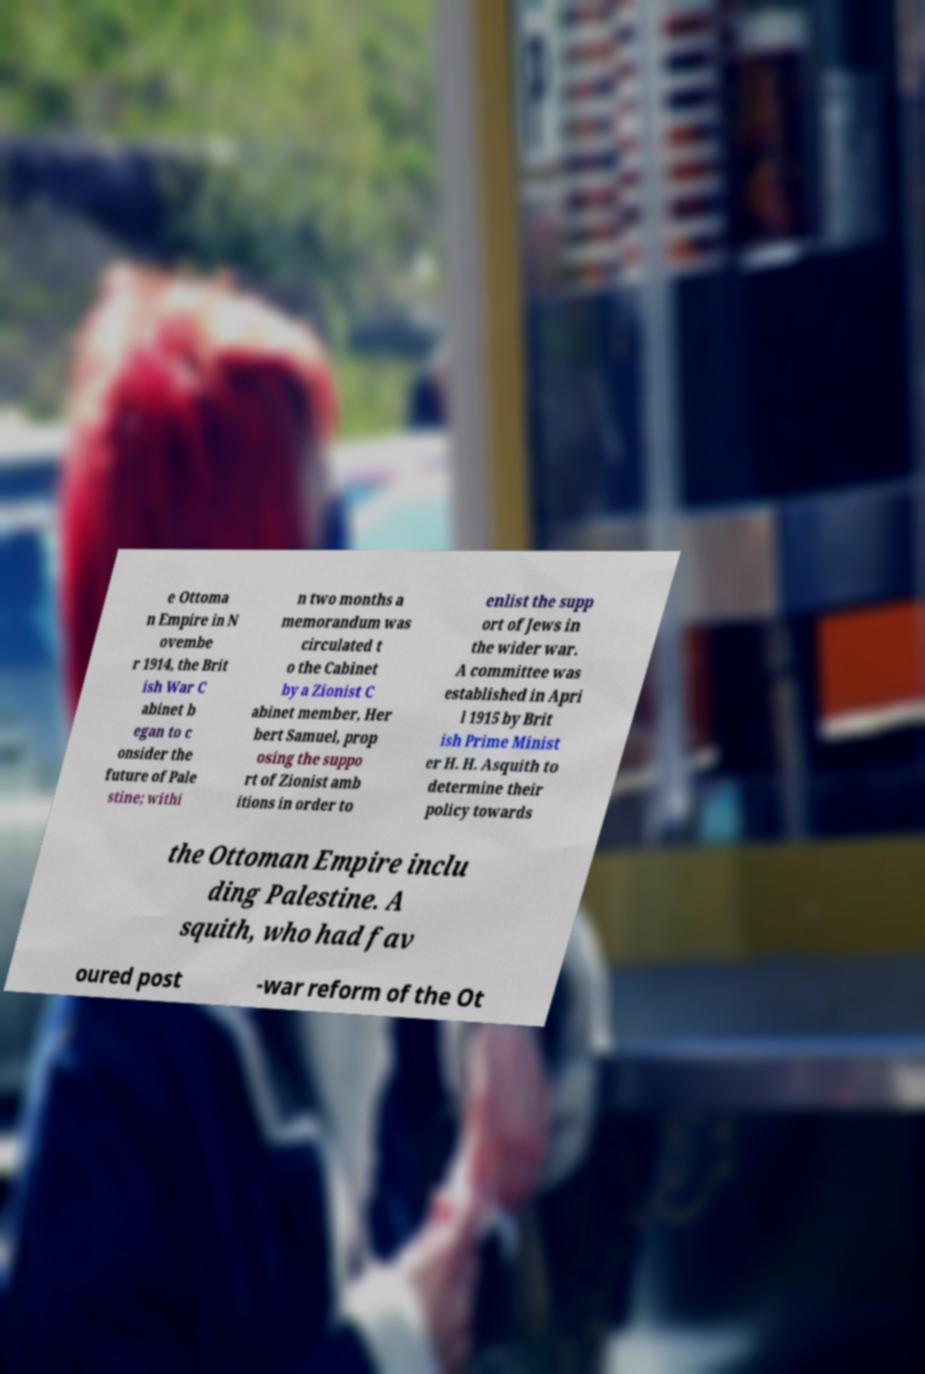Please read and relay the text visible in this image. What does it say? e Ottoma n Empire in N ovembe r 1914, the Brit ish War C abinet b egan to c onsider the future of Pale stine; withi n two months a memorandum was circulated t o the Cabinet by a Zionist C abinet member, Her bert Samuel, prop osing the suppo rt of Zionist amb itions in order to enlist the supp ort of Jews in the wider war. A committee was established in Apri l 1915 by Brit ish Prime Minist er H. H. Asquith to determine their policy towards the Ottoman Empire inclu ding Palestine. A squith, who had fav oured post -war reform of the Ot 